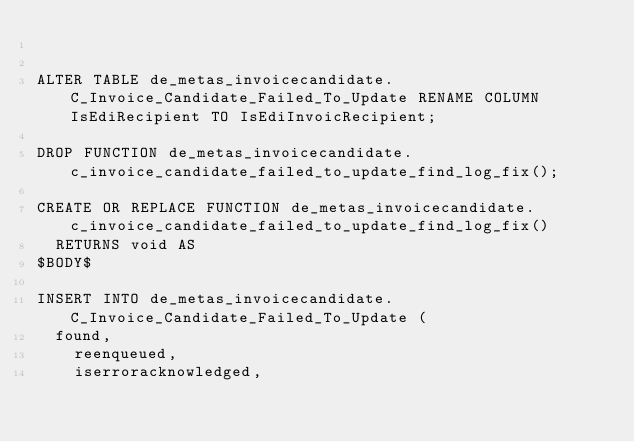Convert code to text. <code><loc_0><loc_0><loc_500><loc_500><_SQL_>

ALTER TABLE de_metas_invoicecandidate.C_Invoice_Candidate_Failed_To_Update RENAME COLUMN IsEdiRecipient TO IsEdiInvoicRecipient;

DROP FUNCTION de_metas_invoicecandidate.c_invoice_candidate_failed_to_update_find_log_fix();

CREATE OR REPLACE FUNCTION de_metas_invoicecandidate.c_invoice_candidate_failed_to_update_find_log_fix()
  RETURNS void AS
$BODY$

INSERT INTO de_metas_invoicecandidate.C_Invoice_Candidate_Failed_To_Update (
	found,
    reenqueued,
    iserroracknowledged,</code> 